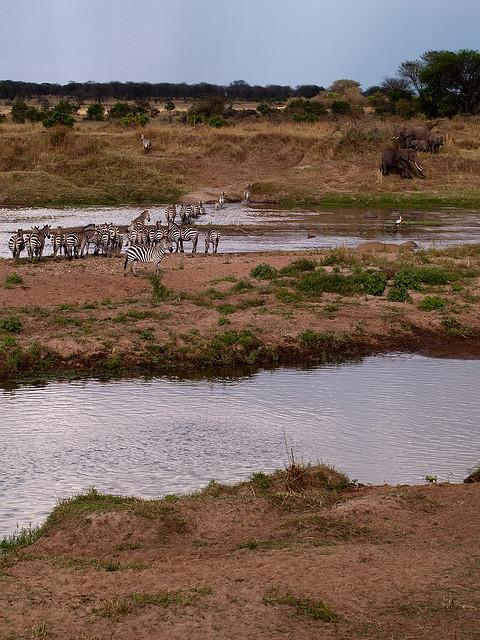How many birds are standing inside of the river with the zebras on the island? Please explain your reasoning. one. One bird can be seen in the water. 